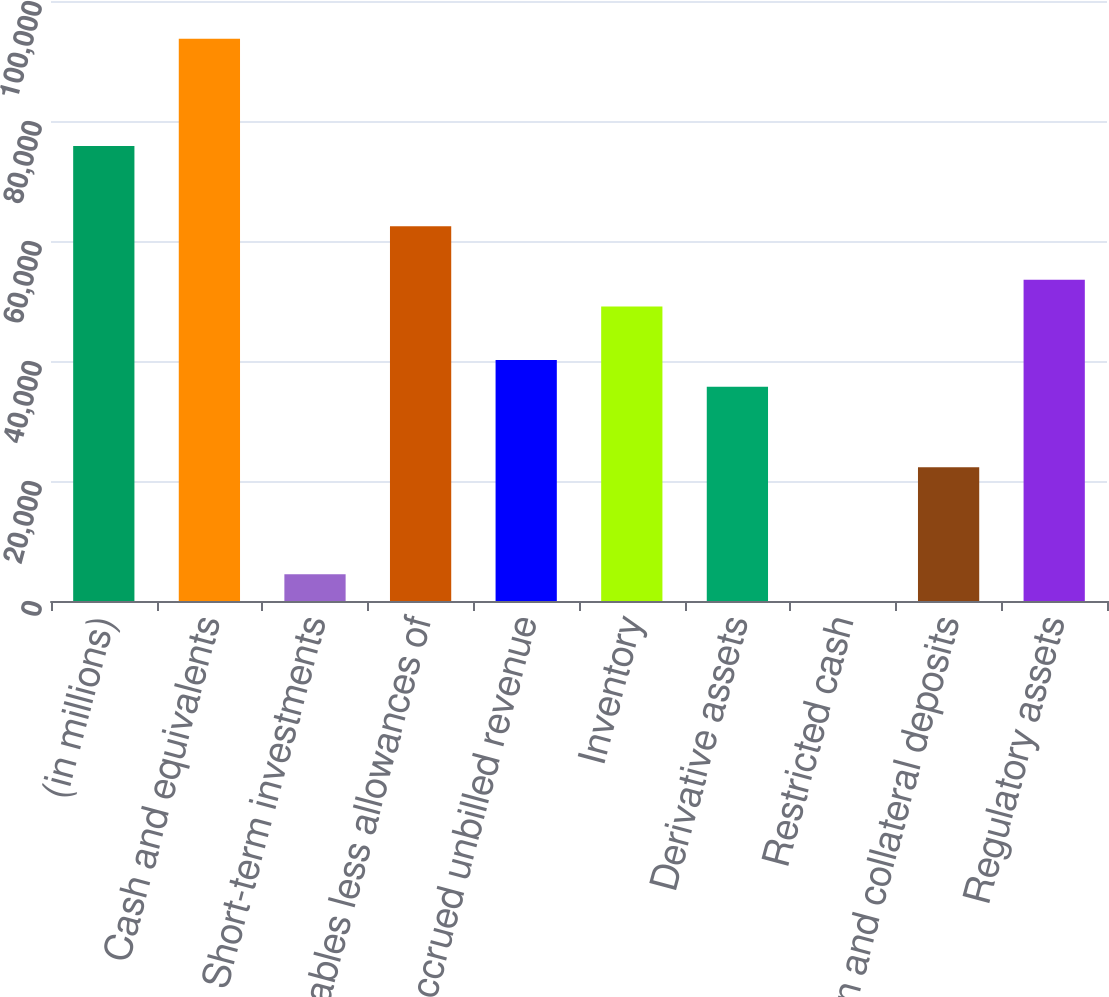Convert chart. <chart><loc_0><loc_0><loc_500><loc_500><bar_chart><fcel>(in millions)<fcel>Cash and equivalents<fcel>Short-term investments<fcel>Receivables less allowances of<fcel>Accrued unbilled revenue<fcel>Inventory<fcel>Derivative assets<fcel>Restricted cash<fcel>Margin and collateral deposits<fcel>Regulatory assets<nl><fcel>75843.4<fcel>93688.2<fcel>4464.2<fcel>62459.8<fcel>40153.8<fcel>49076.2<fcel>35692.6<fcel>3<fcel>22309<fcel>53537.4<nl></chart> 